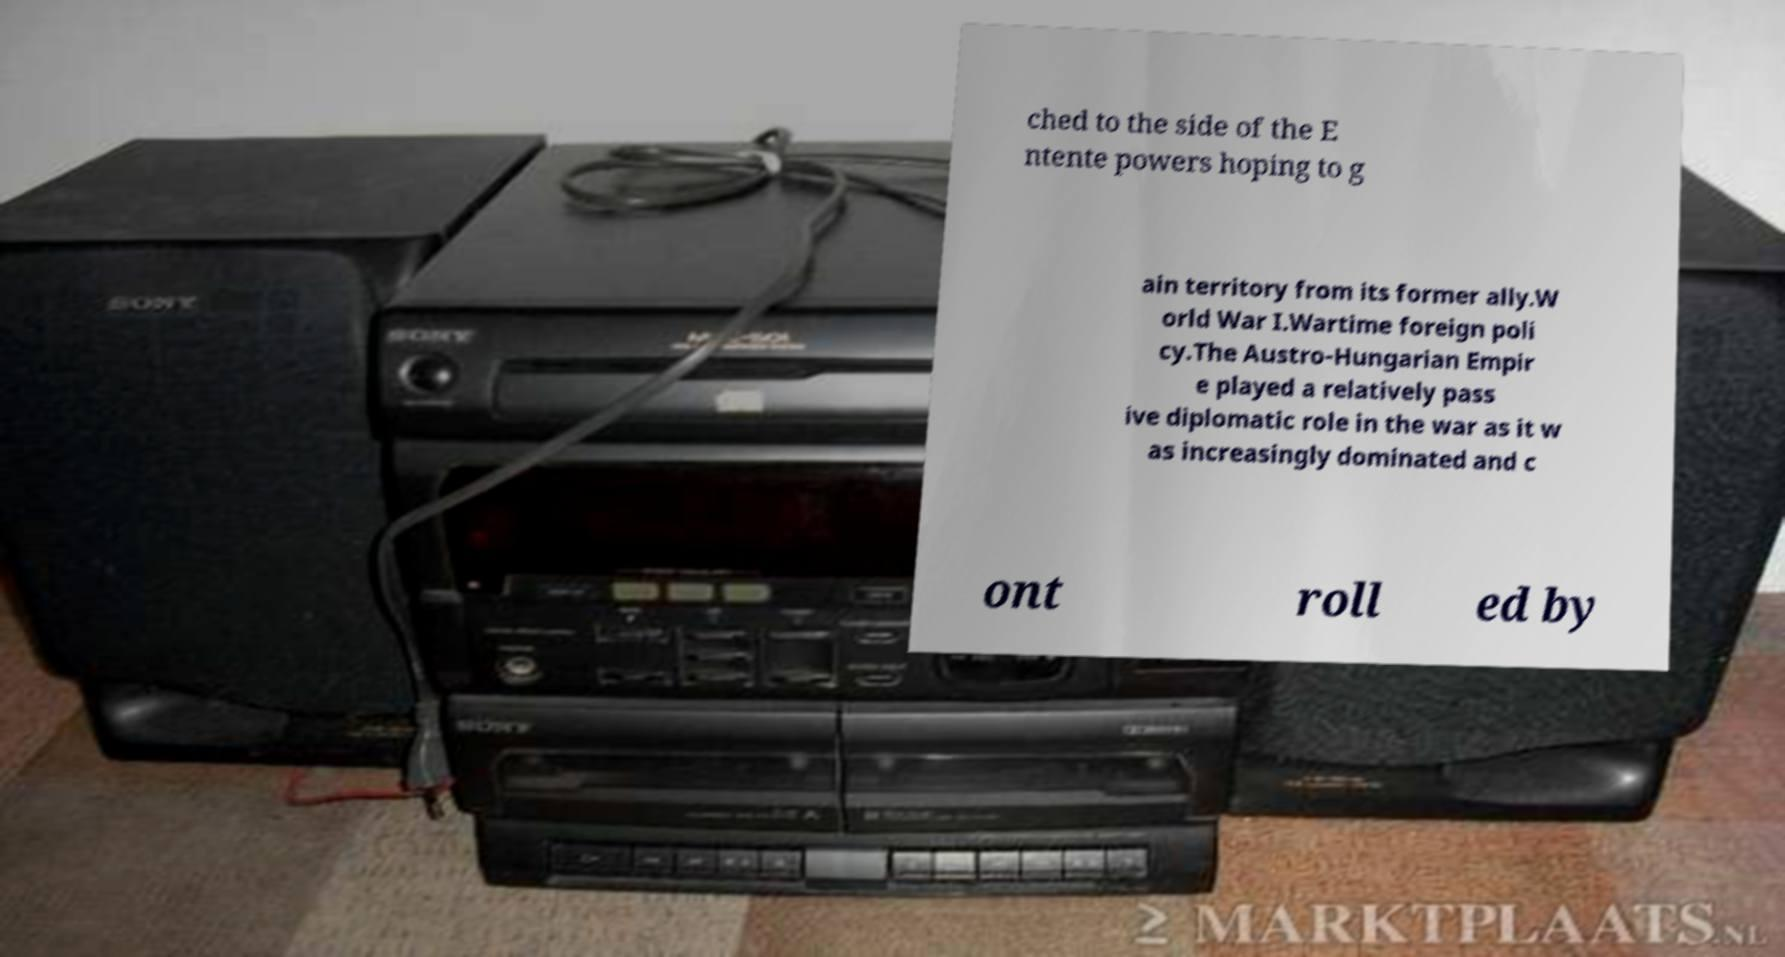There's text embedded in this image that I need extracted. Can you transcribe it verbatim? ched to the side of the E ntente powers hoping to g ain territory from its former ally.W orld War I.Wartime foreign poli cy.The Austro-Hungarian Empir e played a relatively pass ive diplomatic role in the war as it w as increasingly dominated and c ont roll ed by 